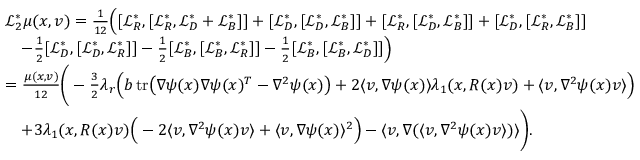<formula> <loc_0><loc_0><loc_500><loc_500>\begin{array} { r l } & { \mathcal { L } _ { 2 } ^ { * } \mu ( x , v ) = \frac { 1 } { 1 2 } \left ( [ \mathcal { L } _ { R } ^ { * } , [ \mathcal { L } _ { R } ^ { * } , \mathcal { L } _ { D } ^ { * } + \mathcal { L } _ { B } ^ { * } ] ] + [ \mathcal { L } _ { D } ^ { * } , [ \mathcal { L } _ { D } ^ { * } , \mathcal { L } _ { B } ^ { * } ] ] + [ \mathcal { L } _ { R } ^ { * } , [ \mathcal { L } _ { D } ^ { * } , \mathcal { L } _ { B } ^ { * } ] ] + [ \mathcal { L } _ { D } ^ { * } , [ \mathcal { L } _ { R } ^ { * } , \mathcal { L } _ { B } ^ { * } ] ] } \\ & { \quad - \frac { 1 } { 2 } [ \mathcal { L } _ { D } ^ { * } , [ \mathcal { L } _ { D } ^ { * } , \mathcal { L } _ { R } ^ { * } ] ] - \frac { 1 } { 2 } [ \mathcal { L } _ { B } ^ { * } , [ \mathcal { L } _ { B } ^ { * } , \mathcal { L } _ { R } ^ { * } ] ] - \frac { 1 } { 2 } [ \mathcal { L } _ { B } ^ { * } , [ \mathcal { L } _ { B } ^ { * } , \mathcal { L } _ { D } ^ { * } ] ] \right ) } \\ & { = \frac { \mu ( x , v ) } { 1 2 } \left ( - \frac { 3 } { 2 } \lambda _ { r } \left ( b \, t r \left ( \nabla \psi ( x ) \nabla \psi ( x ) ^ { T } - \nabla ^ { 2 } \psi ( x ) \right ) + 2 \langle v , \nabla \psi ( x ) \rangle \lambda _ { 1 } ( x , R ( x ) v ) + \langle v , \nabla ^ { 2 } \psi ( x ) v \rangle \right ) } \\ & { \quad + 3 \lambda _ { 1 } ( x , R ( x ) v ) \left ( - 2 \langle v , \nabla ^ { 2 } \psi ( x ) v \rangle + \langle v , \nabla \psi ( x ) \rangle ^ { 2 } \right ) - \langle v , \nabla ( \langle v , \nabla ^ { 2 } \psi ( x ) v \rangle ) \rangle \right ) . } \end{array}</formula> 